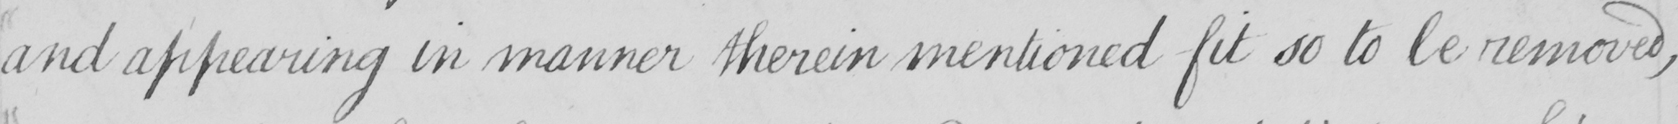What does this handwritten line say? and appearing in manner therein mentioned fit so to be removed , 